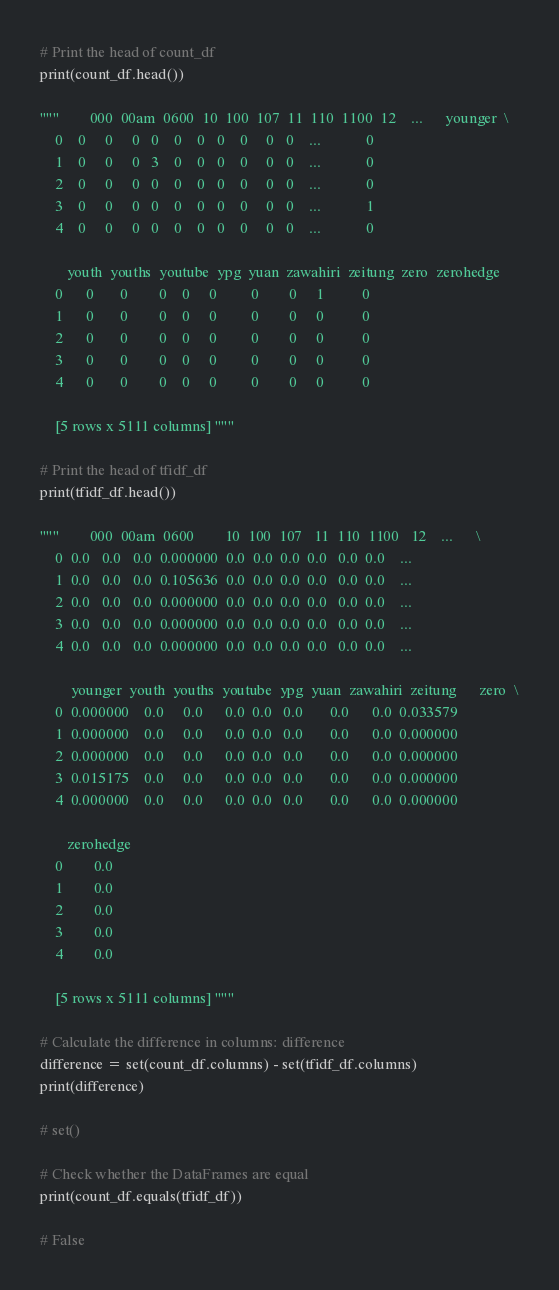Convert code to text. <code><loc_0><loc_0><loc_500><loc_500><_Python_># Print the head of count_df
print(count_df.head())

"""        000  00am  0600  10  100  107  11  110  1100  12    ...      younger  \
    0    0     0     0   0    0    0   0    0     0   0    ...            0   
    1    0     0     0   3    0    0   0    0     0   0    ...            0   
    2    0     0     0   0    0    0   0    0     0   0    ...            0   
    3    0     0     0   0    0    0   0    0     0   0    ...            1   
    4    0     0     0   0    0    0   0    0     0   0    ...            0   
    
       youth  youths  youtube  ypg  yuan  zawahiri  zeitung  zero  zerohedge  
    0      0       0        0    0     0         0        0     1          0  
    1      0       0        0    0     0         0        0     0          0  
    2      0       0        0    0     0         0        0     0          0  
    3      0       0        0    0     0         0        0     0          0  
    4      0       0        0    0     0         0        0     0          0  
    
    [5 rows x 5111 columns] """

# Print the head of tfidf_df
print(tfidf_df.head())

"""        000  00am  0600        10  100  107   11  110  1100   12    ...      \
    0  0.0   0.0   0.0  0.000000  0.0  0.0  0.0  0.0   0.0  0.0    ...       
    1  0.0   0.0   0.0  0.105636  0.0  0.0  0.0  0.0   0.0  0.0    ...       
    2  0.0   0.0   0.0  0.000000  0.0  0.0  0.0  0.0   0.0  0.0    ...       
    3  0.0   0.0   0.0  0.000000  0.0  0.0  0.0  0.0   0.0  0.0    ...       
    4  0.0   0.0   0.0  0.000000  0.0  0.0  0.0  0.0   0.0  0.0    ...       
    
        younger  youth  youths  youtube  ypg  yuan  zawahiri  zeitung      zero  \
    0  0.000000    0.0     0.0      0.0  0.0   0.0       0.0      0.0  0.033579   
    1  0.000000    0.0     0.0      0.0  0.0   0.0       0.0      0.0  0.000000   
    2  0.000000    0.0     0.0      0.0  0.0   0.0       0.0      0.0  0.000000   
    3  0.015175    0.0     0.0      0.0  0.0   0.0       0.0      0.0  0.000000   
    4  0.000000    0.0     0.0      0.0  0.0   0.0       0.0      0.0  0.000000   
    
       zerohedge  
    0        0.0  
    1        0.0  
    2        0.0  
    3        0.0  
    4        0.0  
    
    [5 rows x 5111 columns] """

# Calculate the difference in columns: difference
difference = set(count_df.columns) - set(tfidf_df.columns)
print(difference)

# set()

# Check whether the DataFrames are equal
print(count_df.equals(tfidf_df))

# False</code> 